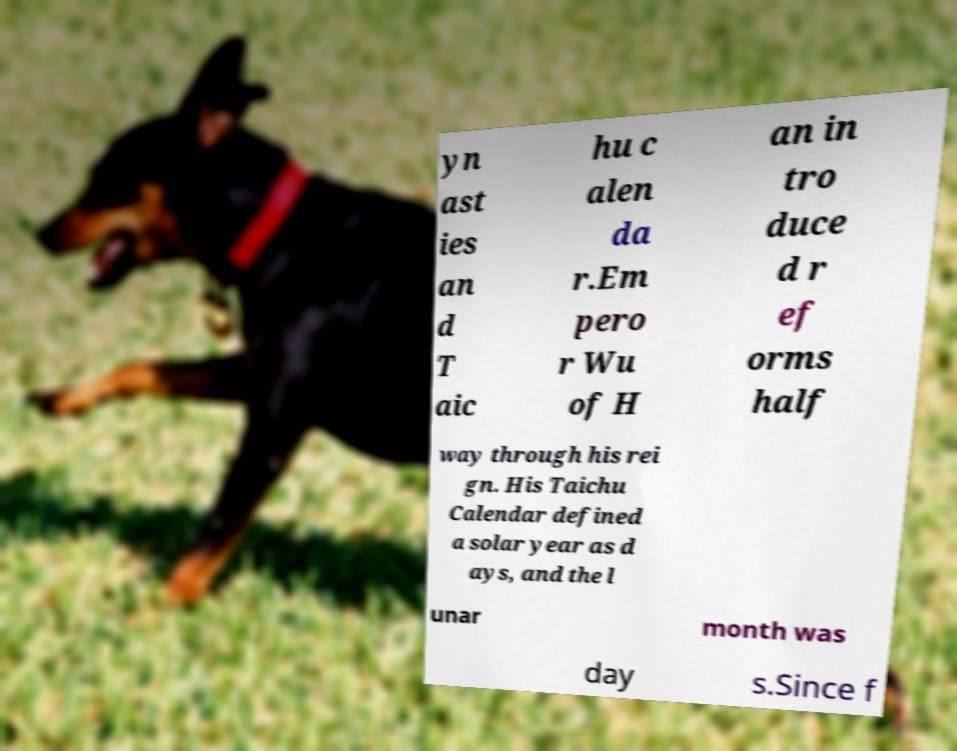What messages or text are displayed in this image? I need them in a readable, typed format. yn ast ies an d T aic hu c alen da r.Em pero r Wu of H an in tro duce d r ef orms half way through his rei gn. His Taichu Calendar defined a solar year as d ays, and the l unar month was day s.Since f 